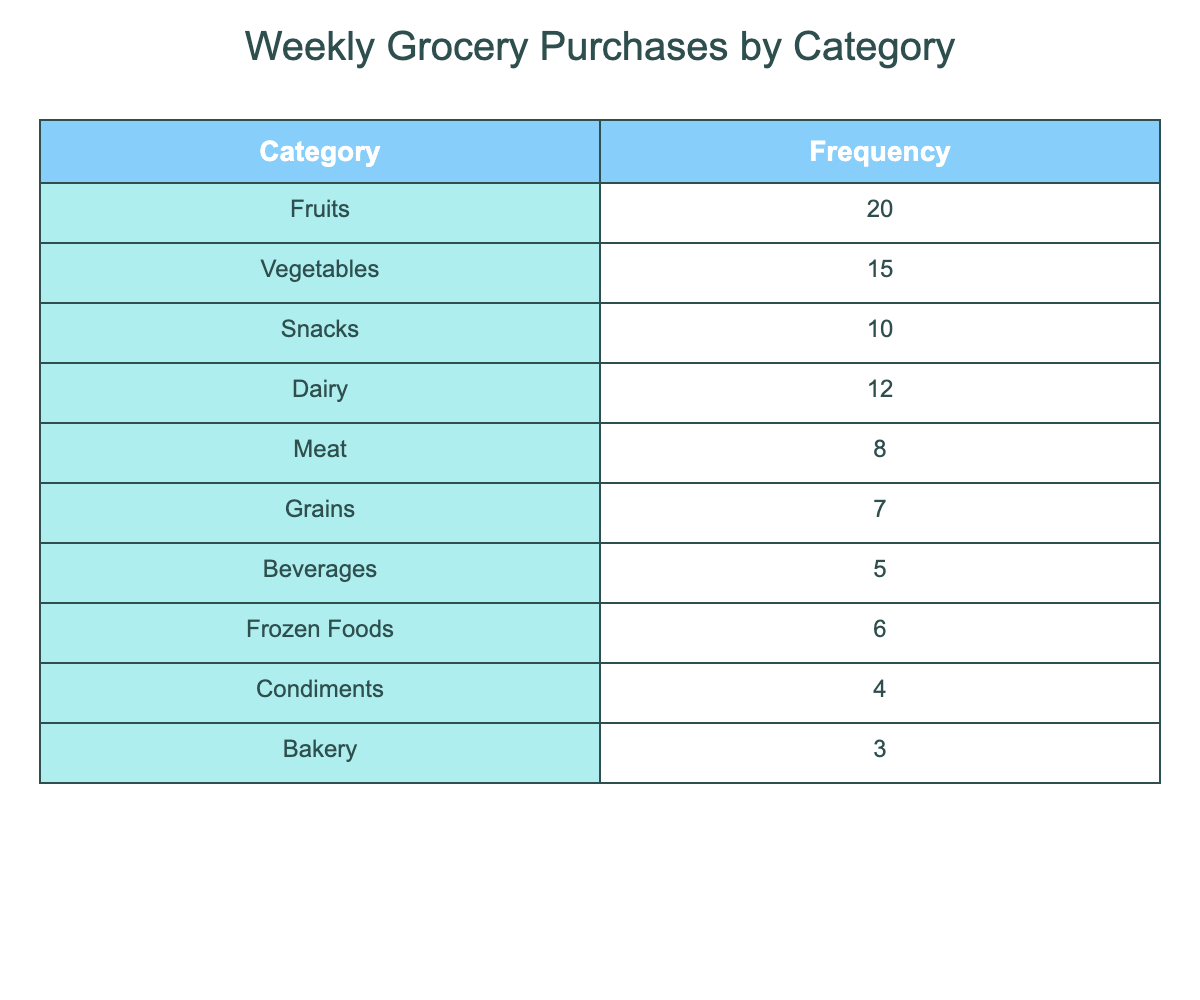What is the most purchased grocery category? The table shows the frequency of grocery purchases by category. By looking at the Frequency column, Fruits has the highest frequency at 20.
Answer: Fruits How many more purchases were made in Fruits compared to Meats? Fruits had 20 purchases and Meats had 8. Subtracting the two (20 - 8) gives 12.
Answer: 12 What is the total number of weekly grocery purchases across all categories? To find the total, we add up all the frequencies: 20 + 15 + 10 + 12 + 8 + 7 + 5 + 6 + 4 + 3 = 90.
Answer: 90 Is the frequency of Dairy purchases greater than Snacks? Dairy has a frequency of 12 and Snacks has 10. Since 12 is greater than 10, the answer is yes.
Answer: Yes What is the average number of purchases across all categories? To calculate the average, first sum the frequencies (90) and then divide by the number of categories (10): 90 / 10 = 9.
Answer: 9 Which category has the least number of purchases? Looking at the Frequency column, Bakery has the lowest frequency at 3.
Answer: Bakery How many purchases were made for Vegetables and Dairy combined? Adding the frequencies for Vegetables (15) and Dairy (12) gives 27 (15 + 12 = 27).
Answer: 27 Is the total for Beverages and Condiments greater than the total for Frozen Foods? Beverages has 5 and Condiments has 4, giving a total of 9. Frozen Foods has 6. Since 9 is greater than 6, the answer is yes.
Answer: Yes What is the difference in frequency between the most and least purchased categories? The most purchased category is Fruits with 20, and the least is Bakery with 3. The difference is 20 - 3 = 17.
Answer: 17 